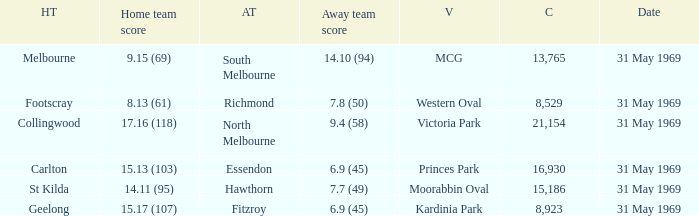Who was the home team in the game where North Melbourne was the away team? 17.16 (118). I'm looking to parse the entire table for insights. Could you assist me with that? {'header': ['HT', 'Home team score', 'AT', 'Away team score', 'V', 'C', 'Date'], 'rows': [['Melbourne', '9.15 (69)', 'South Melbourne', '14.10 (94)', 'MCG', '13,765', '31 May 1969'], ['Footscray', '8.13 (61)', 'Richmond', '7.8 (50)', 'Western Oval', '8,529', '31 May 1969'], ['Collingwood', '17.16 (118)', 'North Melbourne', '9.4 (58)', 'Victoria Park', '21,154', '31 May 1969'], ['Carlton', '15.13 (103)', 'Essendon', '6.9 (45)', 'Princes Park', '16,930', '31 May 1969'], ['St Kilda', '14.11 (95)', 'Hawthorn', '7.7 (49)', 'Moorabbin Oval', '15,186', '31 May 1969'], ['Geelong', '15.17 (107)', 'Fitzroy', '6.9 (45)', 'Kardinia Park', '8,923', '31 May 1969']]} 